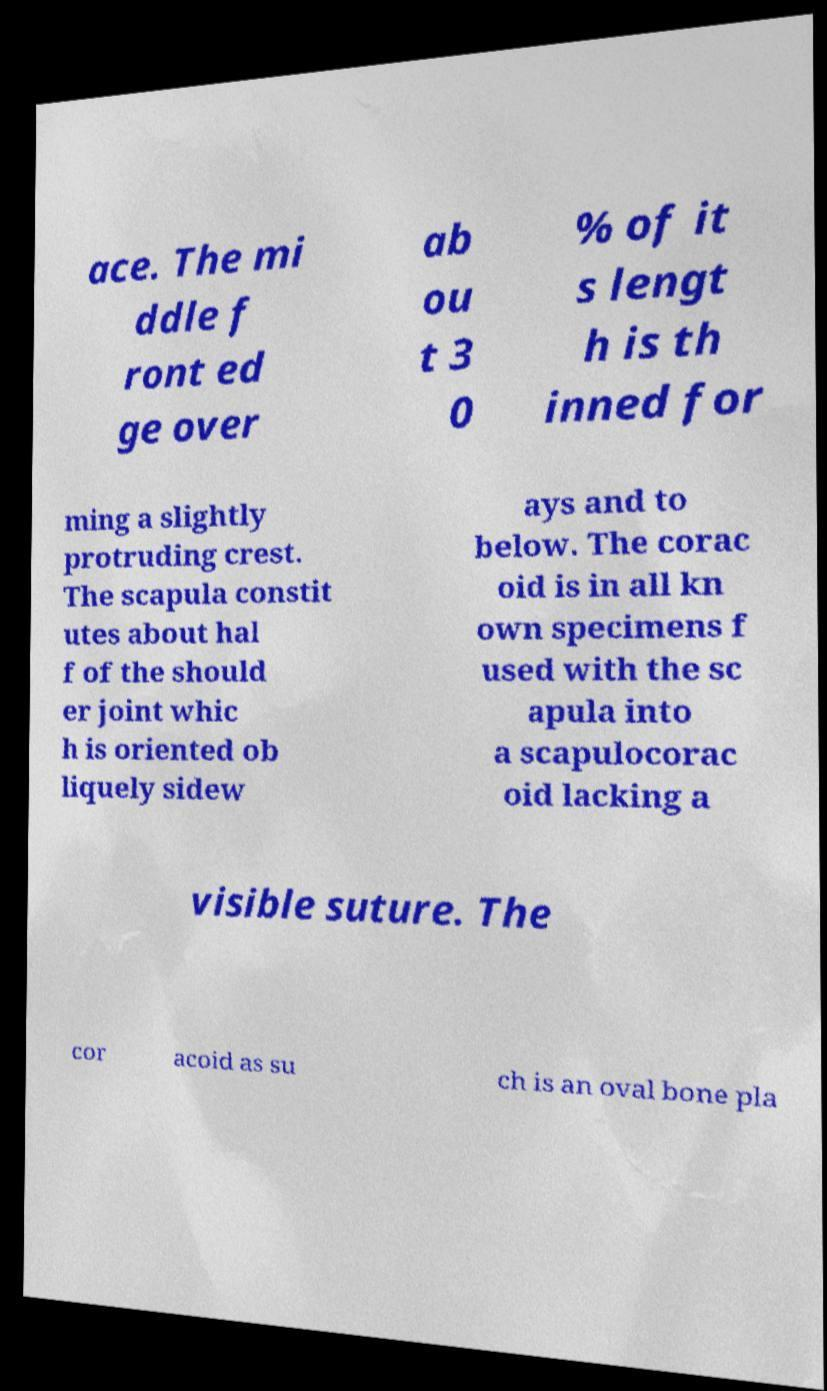Please read and relay the text visible in this image. What does it say? ace. The mi ddle f ront ed ge over ab ou t 3 0 % of it s lengt h is th inned for ming a slightly protruding crest. The scapula constit utes about hal f of the should er joint whic h is oriented ob liquely sidew ays and to below. The corac oid is in all kn own specimens f used with the sc apula into a scapulocorac oid lacking a visible suture. The cor acoid as su ch is an oval bone pla 